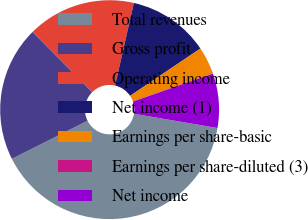<chart> <loc_0><loc_0><loc_500><loc_500><pie_chart><fcel>Total revenues<fcel>Gross profit<fcel>Operating income<fcel>Net income (1)<fcel>Earnings per share-basic<fcel>Earnings per share-diluted (3)<fcel>Net income<nl><fcel>39.9%<fcel>19.98%<fcel>15.99%<fcel>12.01%<fcel>4.04%<fcel>0.05%<fcel>8.02%<nl></chart> 